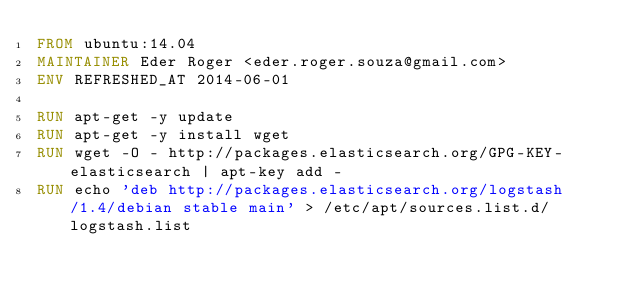Convert code to text. <code><loc_0><loc_0><loc_500><loc_500><_Dockerfile_>FROM ubuntu:14.04
MAINTAINER Eder Roger <eder.roger.souza@gmail.com>
ENV REFRESHED_AT 2014-06-01

RUN apt-get -y update
RUN apt-get -y install wget
RUN wget -O - http://packages.elasticsearch.org/GPG-KEY-elasticsearch | apt-key add -
RUN echo 'deb http://packages.elasticsearch.org/logstash/1.4/debian stable main' > /etc/apt/sources.list.d/logstash.list</code> 